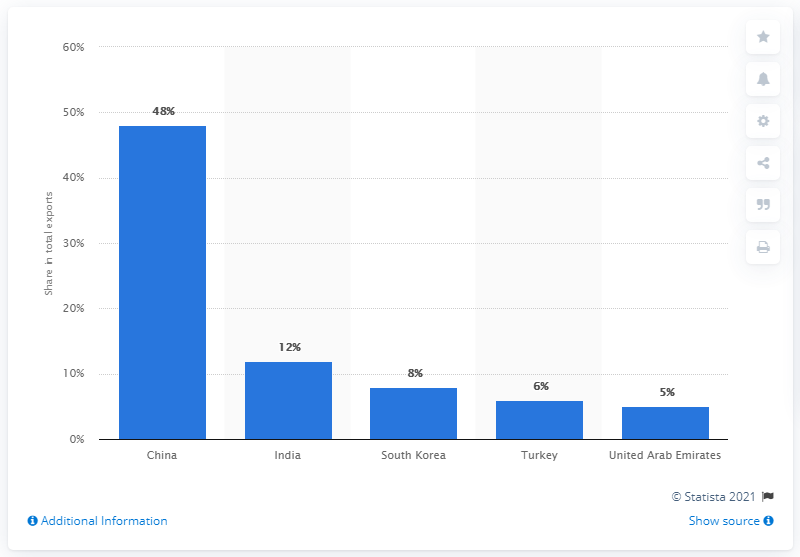Identify some key points in this picture. In 2019, China was Iran's primary export partner, representing the largest share of the country's international exports. 